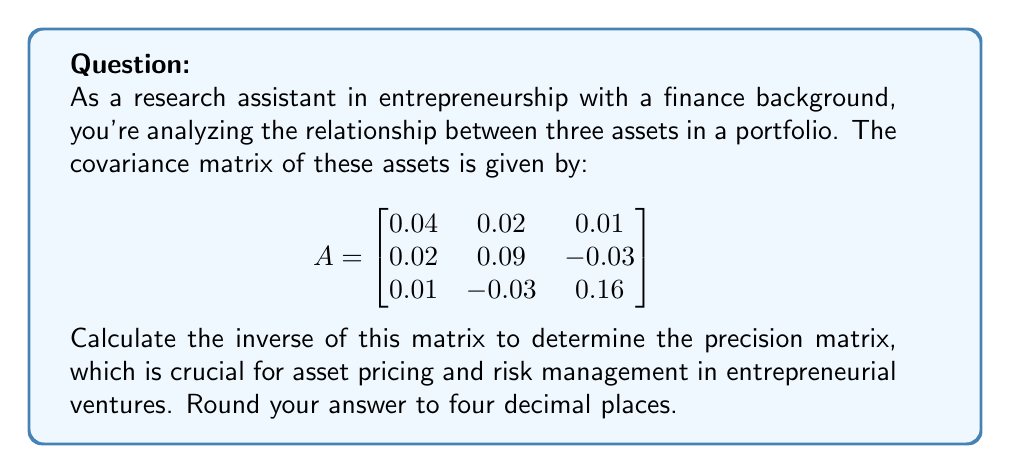Show me your answer to this math problem. To find the inverse of matrix $A$, we'll use the following steps:

1) First, calculate the determinant of $A$:
   $det(A) = 0.04(0.09 \cdot 0.16 - (-0.03)^2) - 0.02(0.02 \cdot 0.16 - 0.01 \cdot (-0.03)) + 0.01(0.02 \cdot (-0.03) - 0.01 \cdot 0.09)$
   $= 0.04(0.0144 - 0.0009) - 0.02(0.0032 + 0.0003) + 0.01(-0.0006 - 0.0009)$
   $= 0.0054 - 0.00007 - 0.000015 = 0.005315$

2) Now, find the adjugate matrix:
   $adj(A) = \begin{bmatrix}
   (0.09 \cdot 0.16 - (-0.03)^2) & -(0.02 \cdot 0.16 - 0.01 \cdot (-0.03)) & (0.02 \cdot (-0.03) - 0.01 \cdot 0.09) \\
   -(0.02 \cdot 0.16 - 0.01 \cdot (-0.03)) & (0.04 \cdot 0.16 - 0.01^2) & -(0.04 \cdot (-0.03) - 0.01 \cdot 0.02) \\
   (0.02 \cdot (-0.03) - 0.01 \cdot 0.02) & -(0.04 \cdot (-0.03) - 0.01 \cdot 0.02) & (0.04 \cdot 0.09 - 0.02^2)
   \end{bmatrix}$

   $= \begin{bmatrix}
   0.0135 & -0.0035 & -0.0015 \\
   -0.0035 & 0.0063 & -0.0005 \\
   -0.0015 & -0.0005 & 0.0032
   \end{bmatrix}$

3) The inverse is given by $A^{-1} = \frac{1}{det(A)} \cdot adj(A)$:

   $A^{-1} = \frac{1}{0.005315} \cdot \begin{bmatrix}
   0.0135 & -0.0035 & -0.0015 \\
   -0.0035 & 0.0063 & -0.0005 \\
   -0.0015 & -0.0005 & 0.0032
   \end{bmatrix}$

4) Performing the multiplication and rounding to 4 decimal places:

   $A^{-1} = \begin{bmatrix}
   2.5400 & -0.6585 & -0.2822 \\
   -0.6585 & 1.1853 & -0.0941 \\
   -0.2822 & -0.0941 & 0.6021
   \end{bmatrix}$
Answer: $$A^{-1} = \begin{bmatrix}
2.5400 & -0.6585 & -0.2822 \\
-0.6585 & 1.1853 & -0.0941 \\
-0.2822 & -0.0941 & 0.6021
\end{bmatrix}$$ 